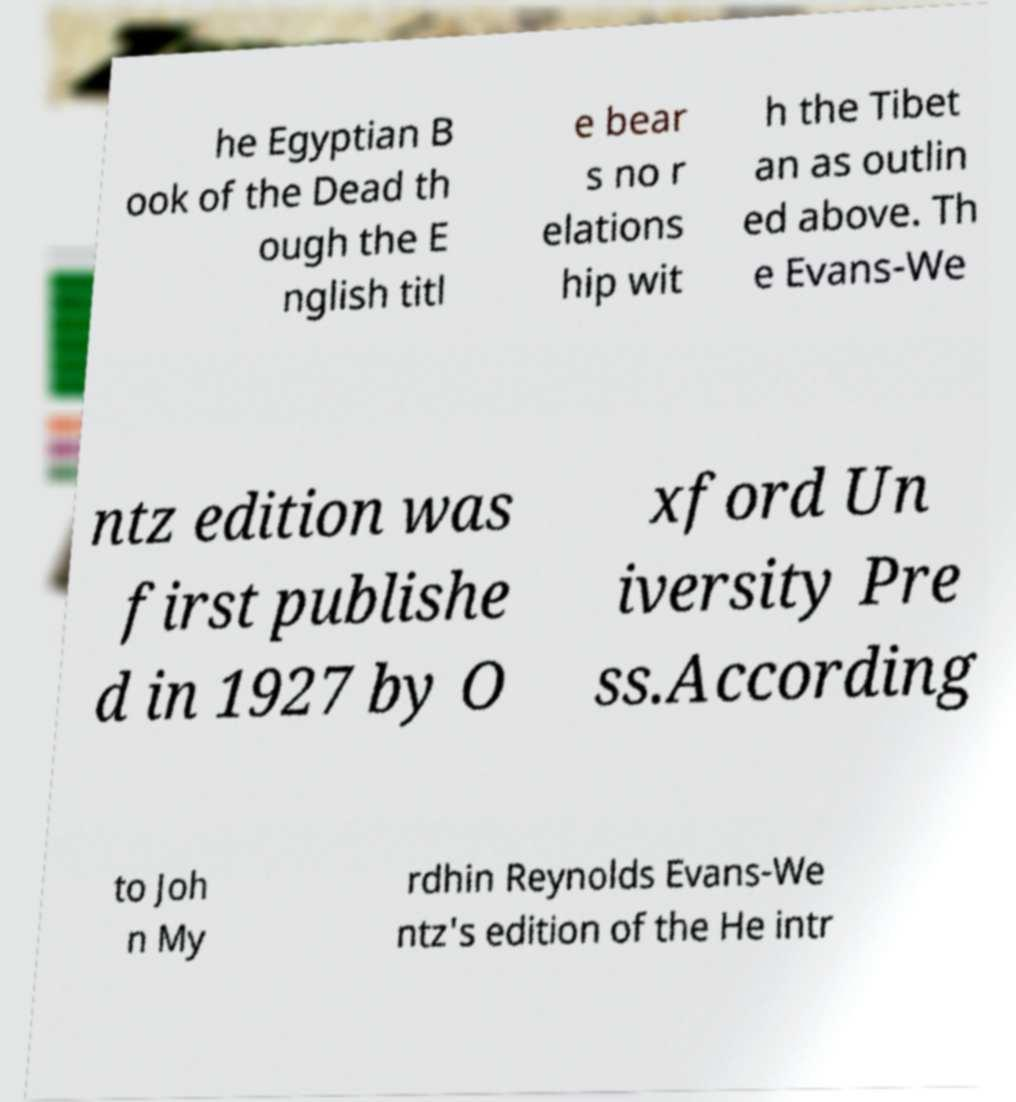Please read and relay the text visible in this image. What does it say? he Egyptian B ook of the Dead th ough the E nglish titl e bear s no r elations hip wit h the Tibet an as outlin ed above. Th e Evans-We ntz edition was first publishe d in 1927 by O xford Un iversity Pre ss.According to Joh n My rdhin Reynolds Evans-We ntz's edition of the He intr 